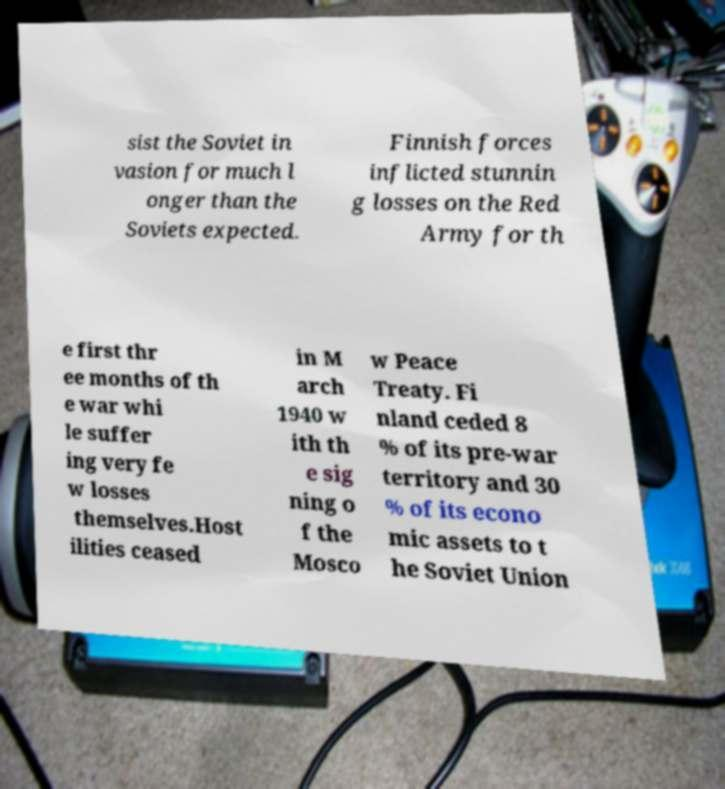For documentation purposes, I need the text within this image transcribed. Could you provide that? sist the Soviet in vasion for much l onger than the Soviets expected. Finnish forces inflicted stunnin g losses on the Red Army for th e first thr ee months of th e war whi le suffer ing very fe w losses themselves.Host ilities ceased in M arch 1940 w ith th e sig ning o f the Mosco w Peace Treaty. Fi nland ceded 8 % of its pre-war territory and 30 % of its econo mic assets to t he Soviet Union 